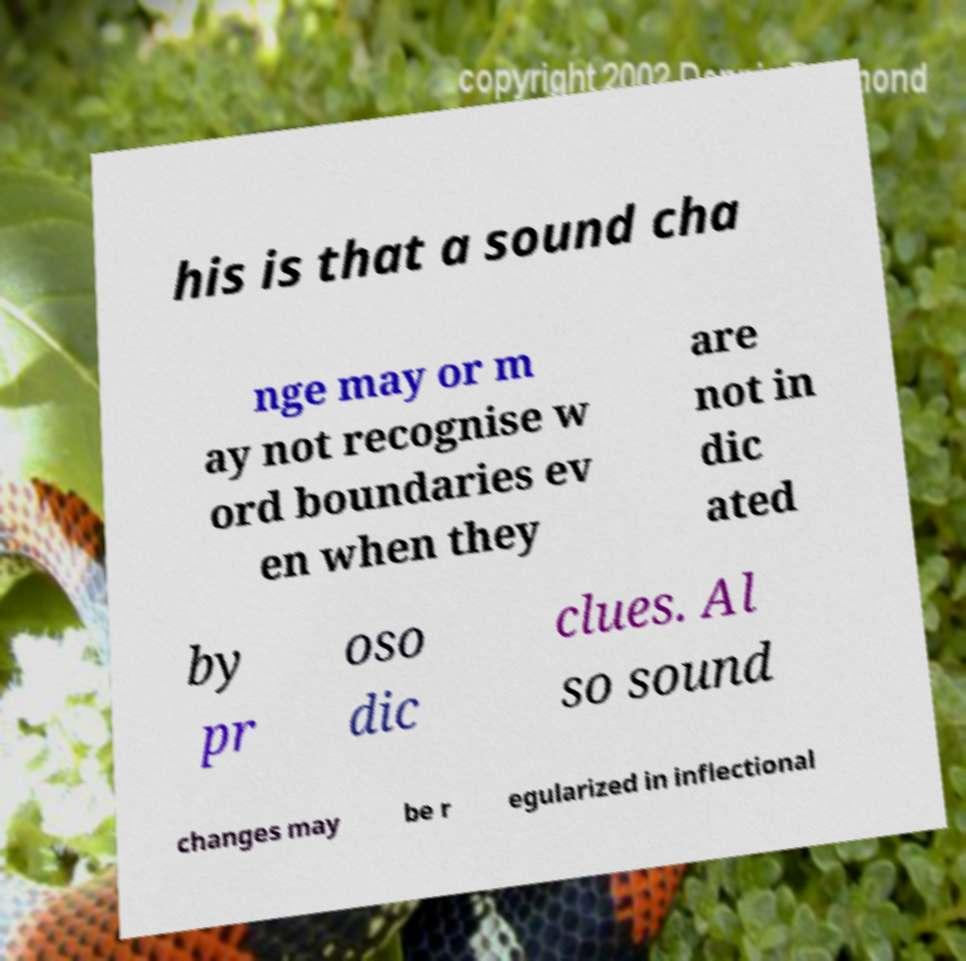Can you read and provide the text displayed in the image?This photo seems to have some interesting text. Can you extract and type it out for me? his is that a sound cha nge may or m ay not recognise w ord boundaries ev en when they are not in dic ated by pr oso dic clues. Al so sound changes may be r egularized in inflectional 